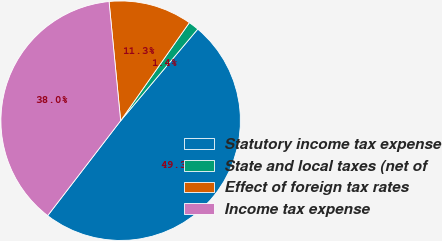Convert chart to OTSL. <chart><loc_0><loc_0><loc_500><loc_500><pie_chart><fcel>Statutory income tax expense<fcel>State and local taxes (net of<fcel>Effect of foreign tax rates<fcel>Income tax expense<nl><fcel>49.3%<fcel>1.41%<fcel>11.27%<fcel>38.03%<nl></chart> 